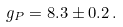<formula> <loc_0><loc_0><loc_500><loc_500>g _ { P } = 8 . 3 \pm 0 . 2 \, .</formula> 